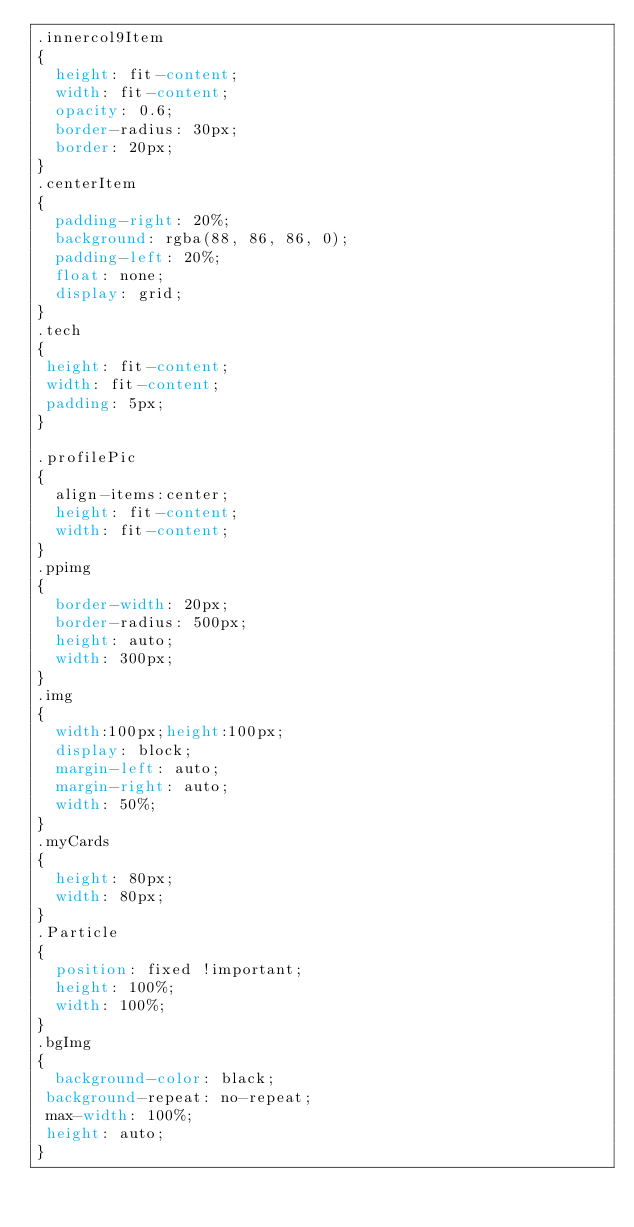<code> <loc_0><loc_0><loc_500><loc_500><_CSS_>.innercol9Item
{
  height: fit-content;
  width: fit-content;
  opacity: 0.6;
  border-radius: 30px;
  border: 20px;
}
.centerItem
{
  padding-right: 20%;
  background: rgba(88, 86, 86, 0);
  padding-left: 20%;
  float: none;
  display: grid;
}
.tech
{
 height: fit-content;
 width: fit-content;
 padding: 5px;
}

.profilePic
{
  align-items:center;
  height: fit-content;
  width: fit-content;
}
.ppimg
{
  border-width: 20px;
  border-radius: 500px;
  height: auto;
  width: 300px;
}
.img
{
  width:100px;height:100px;
  display: block;
  margin-left: auto;
  margin-right: auto;
  width: 50%;
}
.myCards
{
  height: 80px;
  width: 80px;
}
.Particle
{
  position: fixed !important;
  height: 100%;
  width: 100%;
}
.bgImg
{
  background-color: black;
 background-repeat: no-repeat;
 max-width: 100%;
 height: auto;
}</code> 